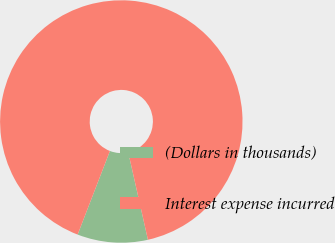Convert chart to OTSL. <chart><loc_0><loc_0><loc_500><loc_500><pie_chart><fcel>(Dollars in thousands)<fcel>Interest expense incurred<nl><fcel>9.39%<fcel>90.61%<nl></chart> 